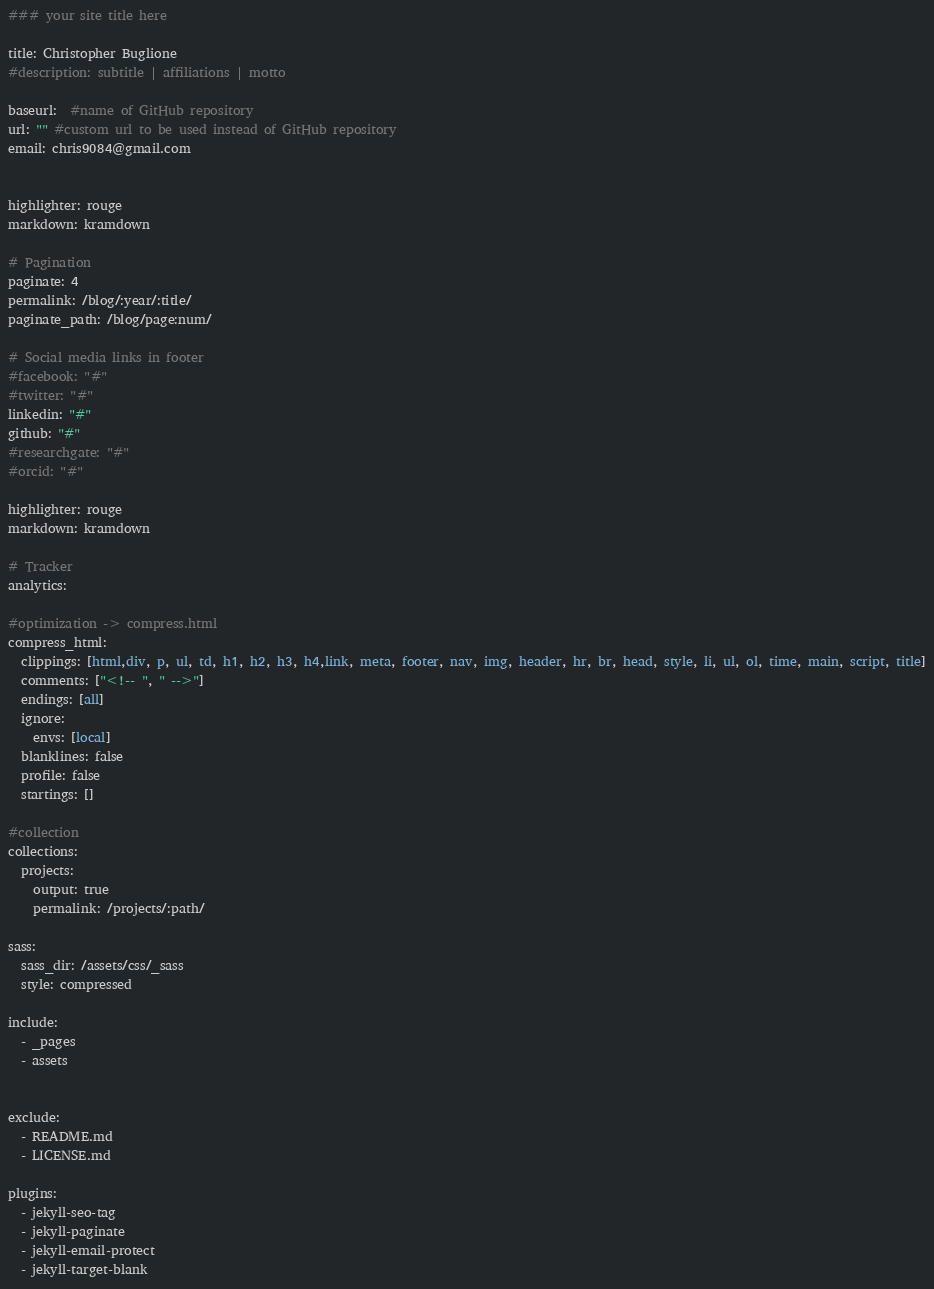<code> <loc_0><loc_0><loc_500><loc_500><_YAML_>### your site title here

title: Christopher Buglione
#description: subtitle | affiliations | motto

baseurl:  #name of GitHub repository
url: "" #custom url to be used instead of GitHub repository
email: chris9084@gmail.com


highlighter: rouge
markdown: kramdown

# Pagination
paginate: 4
permalink: /blog/:year/:title/
paginate_path: /blog/page:num/

# Social media links in footer
#facebook: "#"
#twitter: "#"
linkedin: "#"
github: "#"
#researchgate: "#"
#orcid: "#"

highlighter: rouge
markdown: kramdown

# Tracker
analytics:

#optimization -> compress.html
compress_html:
  clippings: [html,div, p, ul, td, h1, h2, h3, h4,link, meta, footer, nav, img, header, hr, br, head, style, li, ul, ol, time, main, script, title]
  comments: ["<!-- ", " -->"]
  endings: [all]
  ignore:
    envs: [local]
  blanklines: false
  profile: false
  startings: []

#collection
collections:
  projects:
    output: true
    permalink: /projects/:path/

sass:
  sass_dir: /assets/css/_sass
  style: compressed

include:
  - _pages
  - assets


exclude:
  - README.md
  - LICENSE.md

plugins:
  - jekyll-seo-tag
  - jekyll-paginate
  - jekyll-email-protect
  - jekyll-target-blank
</code> 